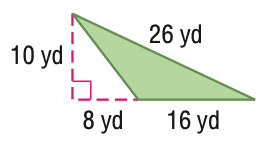Answer the mathemtical geometry problem and directly provide the correct option letter.
Question: Find the area of the figure. Round to the nearest tenth if necessary.
Choices: A: 40 B: 80 C: 120 D: 160 B 